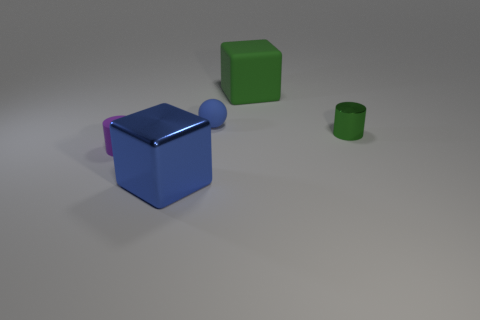Add 1 red shiny cubes. How many objects exist? 6 Subtract all balls. How many objects are left? 4 Subtract all large green things. Subtract all purple objects. How many objects are left? 3 Add 4 purple matte cylinders. How many purple matte cylinders are left? 5 Add 2 big brown blocks. How many big brown blocks exist? 2 Subtract 0 red cylinders. How many objects are left? 5 